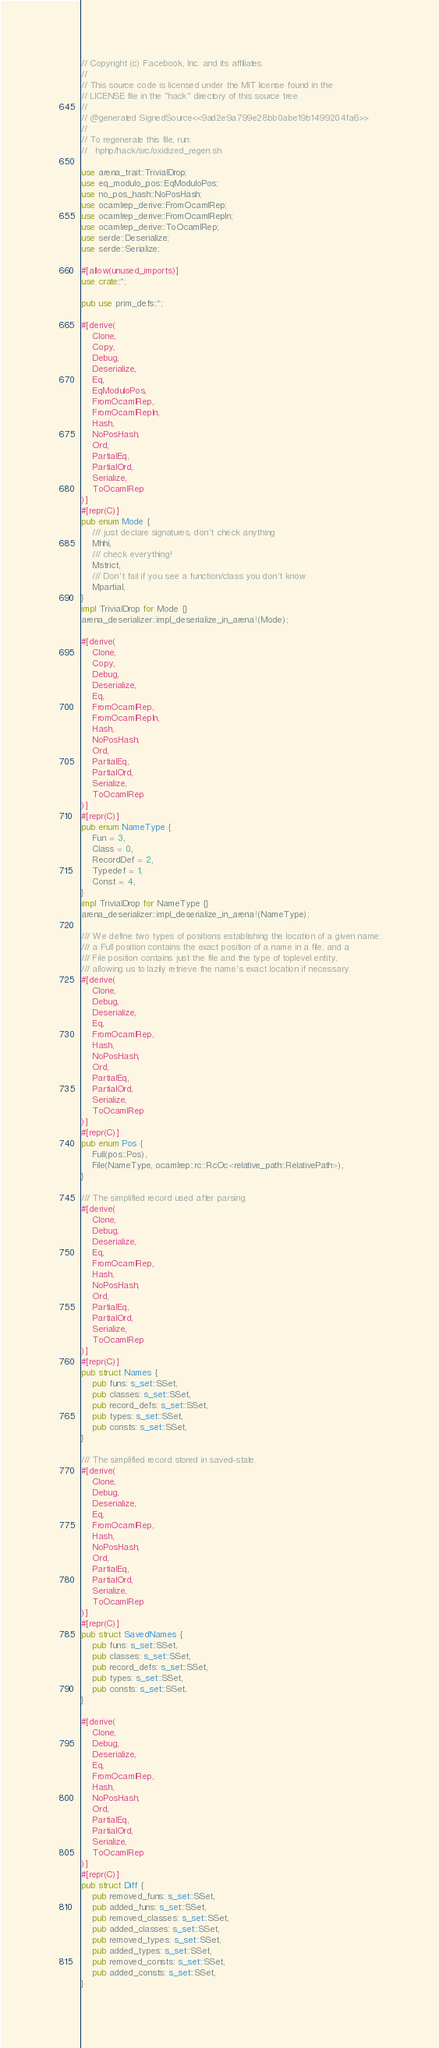Convert code to text. <code><loc_0><loc_0><loc_500><loc_500><_Rust_>// Copyright (c) Facebook, Inc. and its affiliates.
//
// This source code is licensed under the MIT license found in the
// LICENSE file in the "hack" directory of this source tree.
//
// @generated SignedSource<<9ad2e9a799e28bb0abe19b1499204fa6>>
//
// To regenerate this file, run:
//   hphp/hack/src/oxidized_regen.sh

use arena_trait::TrivialDrop;
use eq_modulo_pos::EqModuloPos;
use no_pos_hash::NoPosHash;
use ocamlrep_derive::FromOcamlRep;
use ocamlrep_derive::FromOcamlRepIn;
use ocamlrep_derive::ToOcamlRep;
use serde::Deserialize;
use serde::Serialize;

#[allow(unused_imports)]
use crate::*;

pub use prim_defs::*;

#[derive(
    Clone,
    Copy,
    Debug,
    Deserialize,
    Eq,
    EqModuloPos,
    FromOcamlRep,
    FromOcamlRepIn,
    Hash,
    NoPosHash,
    Ord,
    PartialEq,
    PartialOrd,
    Serialize,
    ToOcamlRep
)]
#[repr(C)]
pub enum Mode {
    /// just declare signatures, don't check anything
    Mhhi,
    /// check everything!
    Mstrict,
    /// Don't fail if you see a function/class you don't know
    Mpartial,
}
impl TrivialDrop for Mode {}
arena_deserializer::impl_deserialize_in_arena!(Mode);

#[derive(
    Clone,
    Copy,
    Debug,
    Deserialize,
    Eq,
    FromOcamlRep,
    FromOcamlRepIn,
    Hash,
    NoPosHash,
    Ord,
    PartialEq,
    PartialOrd,
    Serialize,
    ToOcamlRep
)]
#[repr(C)]
pub enum NameType {
    Fun = 3,
    Class = 0,
    RecordDef = 2,
    Typedef = 1,
    Const = 4,
}
impl TrivialDrop for NameType {}
arena_deserializer::impl_deserialize_in_arena!(NameType);

/// We define two types of positions establishing the location of a given name:
/// a Full position contains the exact position of a name in a file, and a
/// File position contains just the file and the type of toplevel entity,
/// allowing us to lazily retrieve the name's exact location if necessary.
#[derive(
    Clone,
    Debug,
    Deserialize,
    Eq,
    FromOcamlRep,
    Hash,
    NoPosHash,
    Ord,
    PartialEq,
    PartialOrd,
    Serialize,
    ToOcamlRep
)]
#[repr(C)]
pub enum Pos {
    Full(pos::Pos),
    File(NameType, ocamlrep::rc::RcOc<relative_path::RelativePath>),
}

/// The simplified record used after parsing.
#[derive(
    Clone,
    Debug,
    Deserialize,
    Eq,
    FromOcamlRep,
    Hash,
    NoPosHash,
    Ord,
    PartialEq,
    PartialOrd,
    Serialize,
    ToOcamlRep
)]
#[repr(C)]
pub struct Names {
    pub funs: s_set::SSet,
    pub classes: s_set::SSet,
    pub record_defs: s_set::SSet,
    pub types: s_set::SSet,
    pub consts: s_set::SSet,
}

/// The simplified record stored in saved-state.
#[derive(
    Clone,
    Debug,
    Deserialize,
    Eq,
    FromOcamlRep,
    Hash,
    NoPosHash,
    Ord,
    PartialEq,
    PartialOrd,
    Serialize,
    ToOcamlRep
)]
#[repr(C)]
pub struct SavedNames {
    pub funs: s_set::SSet,
    pub classes: s_set::SSet,
    pub record_defs: s_set::SSet,
    pub types: s_set::SSet,
    pub consts: s_set::SSet,
}

#[derive(
    Clone,
    Debug,
    Deserialize,
    Eq,
    FromOcamlRep,
    Hash,
    NoPosHash,
    Ord,
    PartialEq,
    PartialOrd,
    Serialize,
    ToOcamlRep
)]
#[repr(C)]
pub struct Diff {
    pub removed_funs: s_set::SSet,
    pub added_funs: s_set::SSet,
    pub removed_classes: s_set::SSet,
    pub added_classes: s_set::SSet,
    pub removed_types: s_set::SSet,
    pub added_types: s_set::SSet,
    pub removed_consts: s_set::SSet,
    pub added_consts: s_set::SSet,
}
</code> 